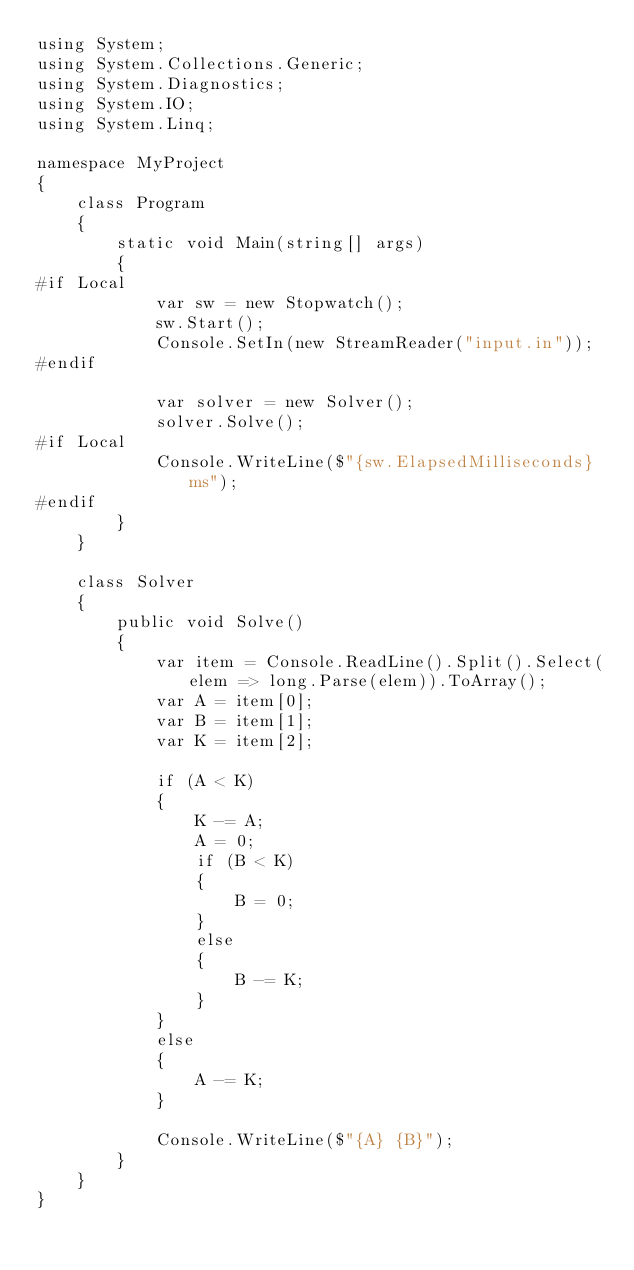Convert code to text. <code><loc_0><loc_0><loc_500><loc_500><_C#_>using System;
using System.Collections.Generic;
using System.Diagnostics;
using System.IO;
using System.Linq;

namespace MyProject
{
    class Program
    {
        static void Main(string[] args)
        {
#if Local
            var sw = new Stopwatch();
            sw.Start();
            Console.SetIn(new StreamReader("input.in"));
#endif

            var solver = new Solver();
            solver.Solve();
#if Local
            Console.WriteLine($"{sw.ElapsedMilliseconds}ms");
#endif
        }
    }

    class Solver
    {
        public void Solve()
        {
            var item = Console.ReadLine().Split().Select(elem => long.Parse(elem)).ToArray();
            var A = item[0];
            var B = item[1];
            var K = item[2];

            if (A < K)
            {
                K -= A;
                A = 0;
                if (B < K)
                {
                    B = 0;
                }
                else
                {
                    B -= K;
                }
            }
            else
            {
                A -= K;
            }

            Console.WriteLine($"{A} {B}");
        }
    }
}
</code> 